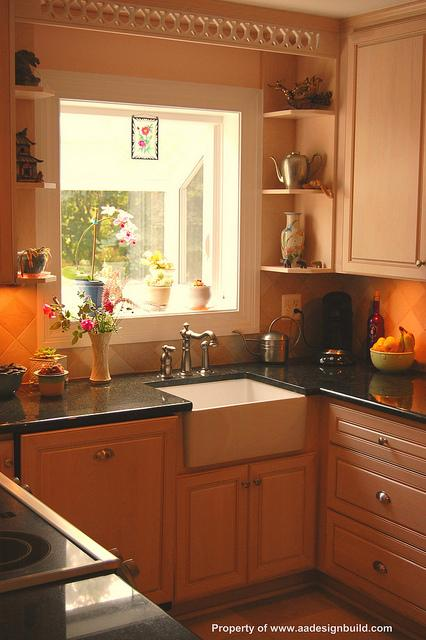What is the type of stove cooktop called? Please explain your reasoning. electric. The type is electric. 